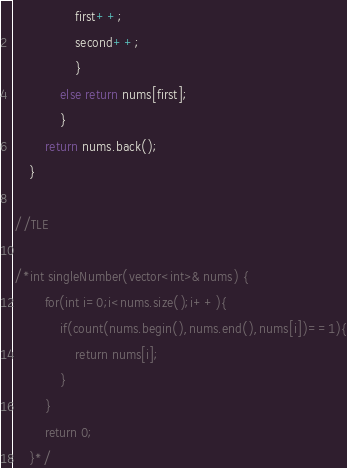Convert code to text. <code><loc_0><loc_0><loc_500><loc_500><_C++_>                first++;
                second++;
                }
            else return nums[first];
            }
        return nums.back();
    }

//TLE

/*int singleNumber(vector<int>& nums) {
        for(int i=0;i<nums.size();i++){
            if(count(nums.begin(),nums.end(),nums[i])==1){
                return nums[i];
            }
        }
        return 0;
    }*/</code> 